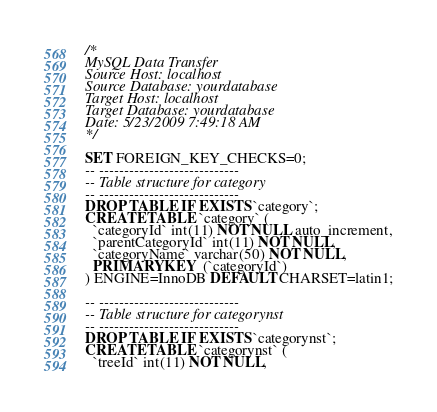<code> <loc_0><loc_0><loc_500><loc_500><_SQL_>/*
MySQL Data Transfer
Source Host: localhost
Source Database: yourdatabase
Target Host: localhost
Target Database: yourdatabase
Date: 5/23/2009 7:49:18 AM
*/

SET FOREIGN_KEY_CHECKS=0;
-- ----------------------------
-- Table structure for category
-- ----------------------------
DROP TABLE IF EXISTS `category`;
CREATE TABLE `category` (
  `categoryId` int(11) NOT NULL auto_increment,
  `parentCategoryId` int(11) NOT NULL,
  `categoryName` varchar(50) NOT NULL,
  PRIMARY KEY  (`categoryId`)
) ENGINE=InnoDB DEFAULT CHARSET=latin1;

-- ----------------------------
-- Table structure for categorynst
-- ----------------------------
DROP TABLE IF EXISTS `categorynst`;
CREATE TABLE `categorynst` (
  `treeId` int(11) NOT NULL,</code> 